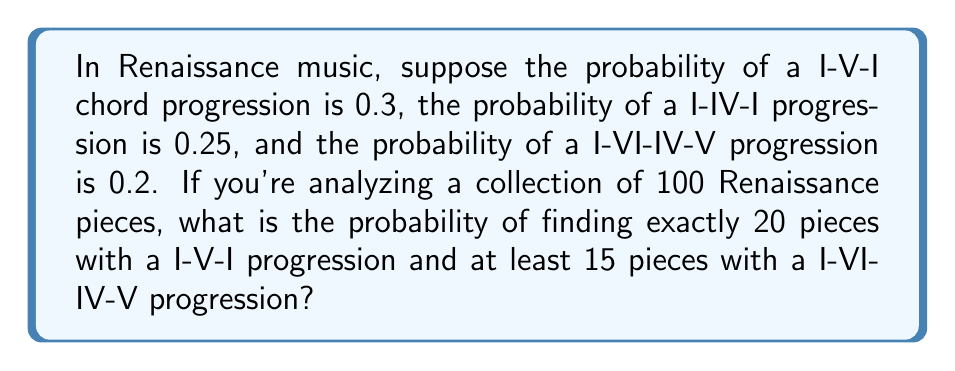Solve this math problem. To solve this problem, we need to use the binomial probability distribution for the I-V-I progression and the cumulative binomial probability for the I-VI-IV-V progression. Let's break it down step by step:

1. For the I-V-I progression:
   We need exactly 20 successes in 100 trials with a probability of 0.3.
   We can use the binomial probability formula:

   $$P(X = k) = \binom{n}{k} p^k (1-p)^{n-k}$$

   Where:
   $n = 100$ (total pieces)
   $k = 20$ (exactly 20 pieces with I-V-I)
   $p = 0.3$ (probability of I-V-I)

   $$P(X = 20) = \binom{100}{20} (0.3)^{20} (0.7)^{80}$$

2. For the I-VI-IV-V progression:
   We need at least 15 successes in 100 trials with a probability of 0.2.
   We can use the cumulative binomial probability:

   $$P(X \geq 15) = 1 - P(X < 15) = 1 - \sum_{k=0}^{14} \binom{100}{k} (0.2)^k (0.8)^{100-k}$$

3. Since these events are independent, we multiply their probabilities:

   $$P(\text{20 I-V-I AND at least 15 I-VI-IV-V}) = P(X = 20) \times P(Y \geq 15)$$

4. Calculate each probability:
   
   $P(X = 20) \approx 0.0888$
   $P(Y \geq 15) \approx 0.8816$

5. Multiply the probabilities:

   $$0.0888 \times 0.8816 \approx 0.0783$$
Answer: The probability of finding exactly 20 pieces with a I-V-I progression and at least 15 pieces with a I-VI-IV-V progression in a collection of 100 Renaissance pieces is approximately 0.0783 or 7.83%. 